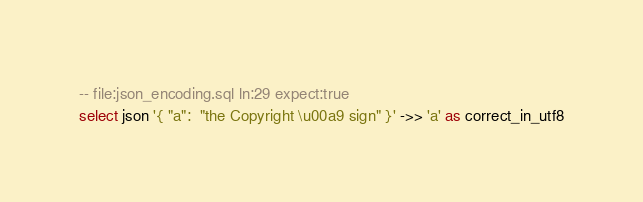<code> <loc_0><loc_0><loc_500><loc_500><_SQL_>-- file:json_encoding.sql ln:29 expect:true
select json '{ "a":  "the Copyright \u00a9 sign" }' ->> 'a' as correct_in_utf8
</code> 